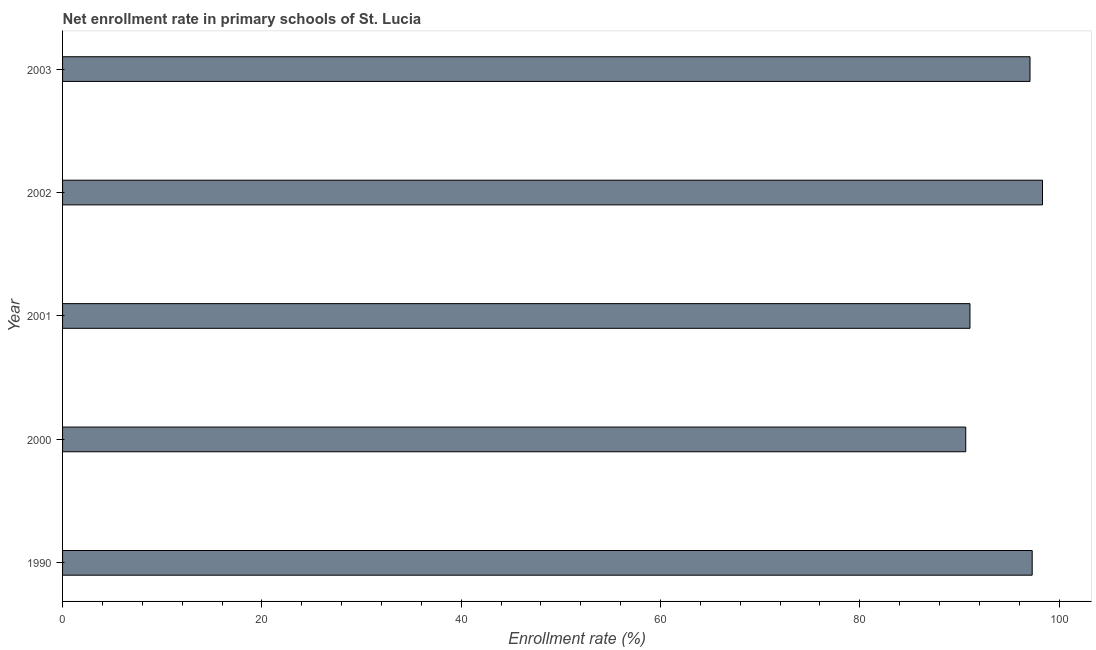Does the graph contain grids?
Offer a terse response. No. What is the title of the graph?
Provide a short and direct response. Net enrollment rate in primary schools of St. Lucia. What is the label or title of the X-axis?
Offer a very short reply. Enrollment rate (%). What is the label or title of the Y-axis?
Provide a short and direct response. Year. What is the net enrollment rate in primary schools in 2000?
Provide a succinct answer. 90.64. Across all years, what is the maximum net enrollment rate in primary schools?
Offer a very short reply. 98.34. Across all years, what is the minimum net enrollment rate in primary schools?
Your answer should be compact. 90.64. In which year was the net enrollment rate in primary schools minimum?
Keep it short and to the point. 2000. What is the sum of the net enrollment rate in primary schools?
Your response must be concise. 474.45. What is the difference between the net enrollment rate in primary schools in 2000 and 2003?
Your response must be concise. -6.45. What is the average net enrollment rate in primary schools per year?
Provide a succinct answer. 94.89. What is the median net enrollment rate in primary schools?
Ensure brevity in your answer.  97.09. Do a majority of the years between 1990 and 2000 (inclusive) have net enrollment rate in primary schools greater than 88 %?
Your answer should be very brief. Yes. What is the ratio of the net enrollment rate in primary schools in 2000 to that in 2002?
Your answer should be very brief. 0.92. What is the difference between the highest and the second highest net enrollment rate in primary schools?
Your answer should be very brief. 1.03. Is the sum of the net enrollment rate in primary schools in 2001 and 2003 greater than the maximum net enrollment rate in primary schools across all years?
Offer a terse response. Yes. In how many years, is the net enrollment rate in primary schools greater than the average net enrollment rate in primary schools taken over all years?
Make the answer very short. 3. How many bars are there?
Offer a very short reply. 5. What is the Enrollment rate (%) in 1990?
Provide a short and direct response. 97.31. What is the Enrollment rate (%) of 2000?
Your answer should be very brief. 90.64. What is the Enrollment rate (%) in 2001?
Provide a succinct answer. 91.06. What is the Enrollment rate (%) in 2002?
Provide a short and direct response. 98.34. What is the Enrollment rate (%) of 2003?
Offer a terse response. 97.09. What is the difference between the Enrollment rate (%) in 1990 and 2000?
Offer a terse response. 6.67. What is the difference between the Enrollment rate (%) in 1990 and 2001?
Keep it short and to the point. 6.24. What is the difference between the Enrollment rate (%) in 1990 and 2002?
Make the answer very short. -1.03. What is the difference between the Enrollment rate (%) in 1990 and 2003?
Keep it short and to the point. 0.22. What is the difference between the Enrollment rate (%) in 2000 and 2001?
Offer a terse response. -0.42. What is the difference between the Enrollment rate (%) in 2000 and 2002?
Your answer should be very brief. -7.7. What is the difference between the Enrollment rate (%) in 2000 and 2003?
Ensure brevity in your answer.  -6.45. What is the difference between the Enrollment rate (%) in 2001 and 2002?
Give a very brief answer. -7.28. What is the difference between the Enrollment rate (%) in 2001 and 2003?
Make the answer very short. -6.03. What is the difference between the Enrollment rate (%) in 2002 and 2003?
Provide a succinct answer. 1.25. What is the ratio of the Enrollment rate (%) in 1990 to that in 2000?
Make the answer very short. 1.07. What is the ratio of the Enrollment rate (%) in 1990 to that in 2001?
Offer a terse response. 1.07. What is the ratio of the Enrollment rate (%) in 2000 to that in 2001?
Offer a very short reply. 0.99. What is the ratio of the Enrollment rate (%) in 2000 to that in 2002?
Your response must be concise. 0.92. What is the ratio of the Enrollment rate (%) in 2000 to that in 2003?
Give a very brief answer. 0.93. What is the ratio of the Enrollment rate (%) in 2001 to that in 2002?
Your response must be concise. 0.93. What is the ratio of the Enrollment rate (%) in 2001 to that in 2003?
Offer a terse response. 0.94. What is the ratio of the Enrollment rate (%) in 2002 to that in 2003?
Offer a terse response. 1.01. 